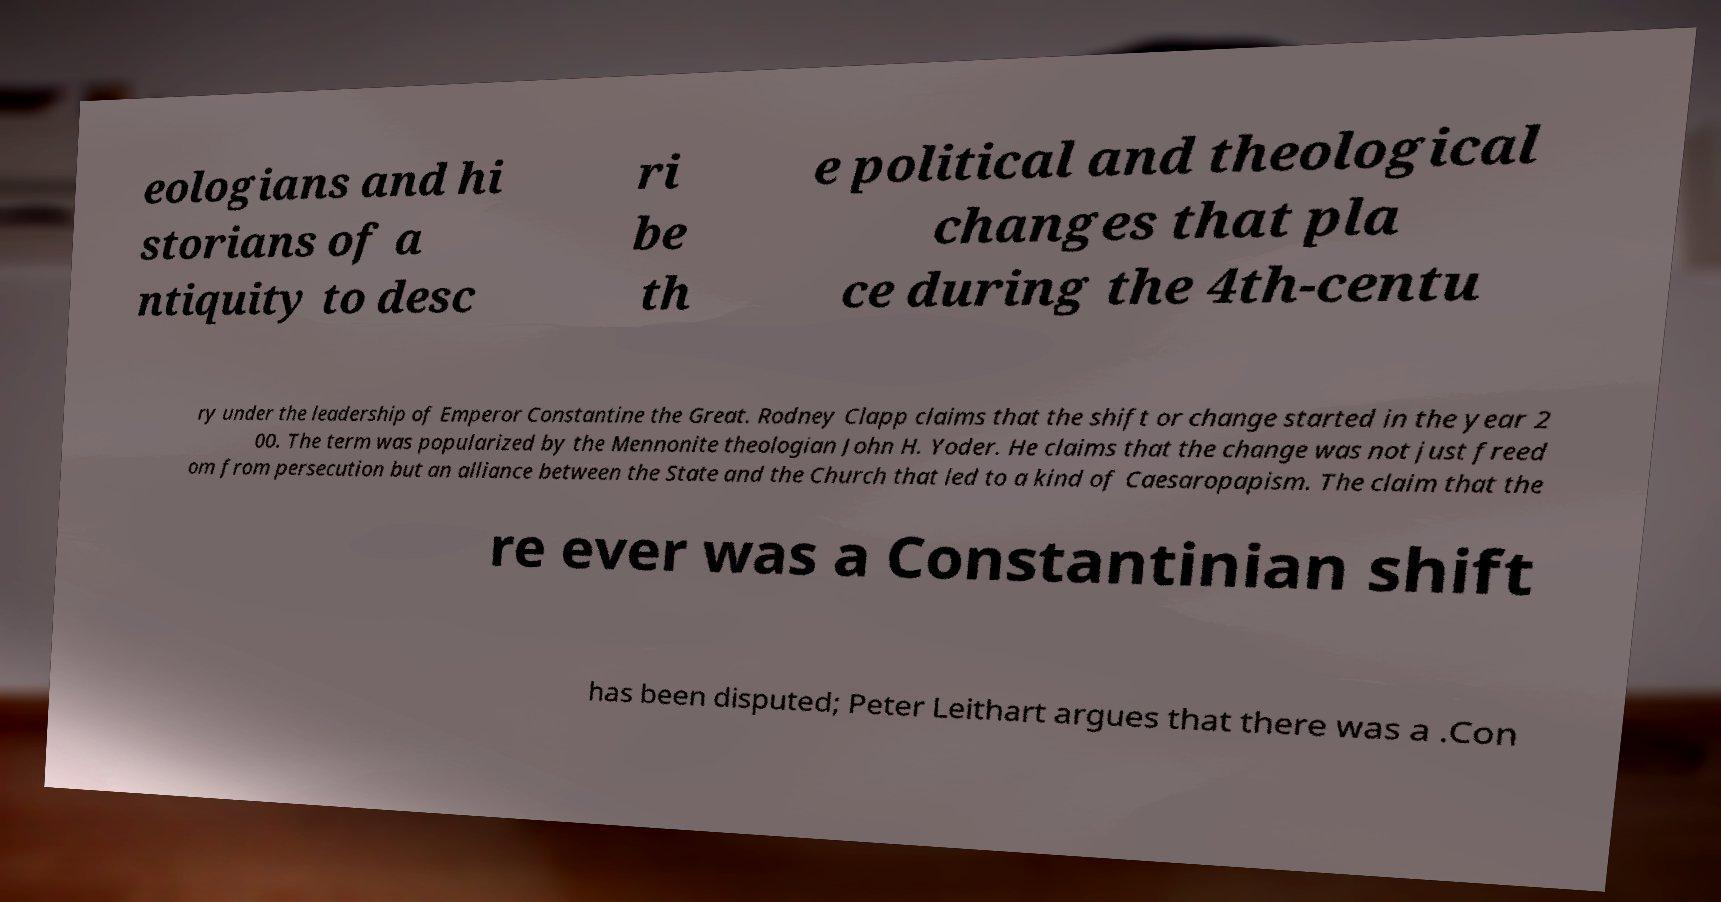For documentation purposes, I need the text within this image transcribed. Could you provide that? eologians and hi storians of a ntiquity to desc ri be th e political and theological changes that pla ce during the 4th-centu ry under the leadership of Emperor Constantine the Great. Rodney Clapp claims that the shift or change started in the year 2 00. The term was popularized by the Mennonite theologian John H. Yoder. He claims that the change was not just freed om from persecution but an alliance between the State and the Church that led to a kind of Caesaropapism. The claim that the re ever was a Constantinian shift has been disputed; Peter Leithart argues that there was a .Con 